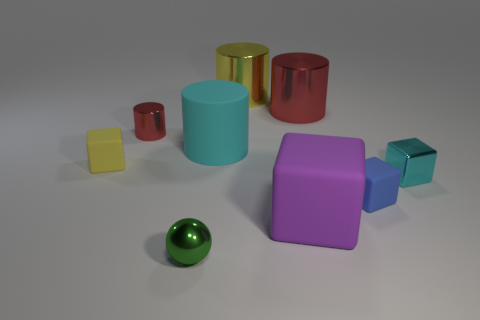Add 1 small cyan metallic objects. How many objects exist? 10 Subtract all cubes. How many objects are left? 5 Subtract all tiny metal cubes. Subtract all small red things. How many objects are left? 7 Add 4 big blocks. How many big blocks are left? 5 Add 3 small red cylinders. How many small red cylinders exist? 4 Subtract 1 cyan cubes. How many objects are left? 8 